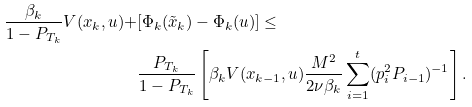<formula> <loc_0><loc_0><loc_500><loc_500>\frac { \beta _ { k } } { 1 - P _ { T _ { k } } } V ( x _ { k } , u ) + & [ \Phi _ { k } ( \tilde { x } _ { k } ) - \Phi _ { k } ( u ) ] \leq \\ & \frac { P _ { T _ { k } } } { 1 - P _ { T _ { k } } } \left [ \beta _ { k } V ( x _ { k - 1 } , u ) \frac { M ^ { 2 } } { 2 \nu \beta _ { k } } \sum _ { i = 1 } ^ { t } ( p _ { i } ^ { 2 } P _ { i - 1 } ) ^ { - 1 } \right ] .</formula> 